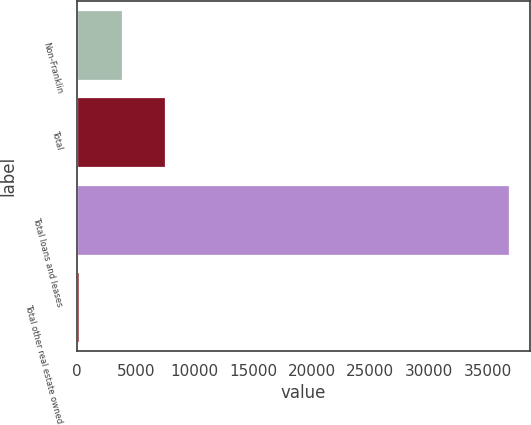Convert chart. <chart><loc_0><loc_0><loc_500><loc_500><bar_chart><fcel>Non-Franklin<fcel>Total<fcel>Total loans and leases<fcel>Total other real estate owned<nl><fcel>3805.16<fcel>7470.22<fcel>36790.7<fcel>140.1<nl></chart> 